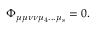<formula> <loc_0><loc_0><loc_500><loc_500>\Phi _ { \mu \mu \nu \nu \mu _ { 4 } \dots \mu _ { s } } = 0 .</formula> 